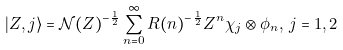<formula> <loc_0><loc_0><loc_500><loc_500>| Z , j \rangle = \mathcal { N } ( Z ) ^ { - \frac { 1 } { 2 } } \sum _ { n = 0 } ^ { \infty } R ( n ) ^ { - \frac { 1 } { 2 } } Z ^ { n } \chi _ { j } \otimes \phi _ { n } , \, j = 1 , 2</formula> 